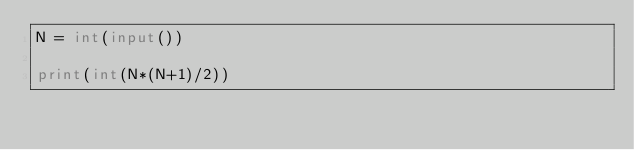Convert code to text. <code><loc_0><loc_0><loc_500><loc_500><_Python_>N = int(input())

print(int(N*(N+1)/2))
</code> 